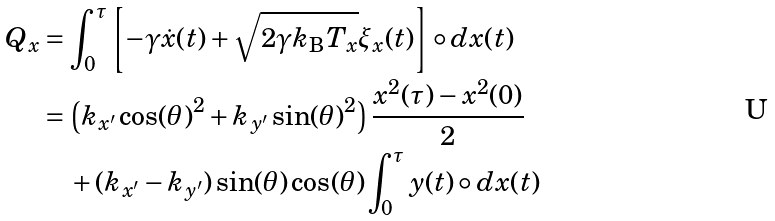<formula> <loc_0><loc_0><loc_500><loc_500>Q _ { x } & = \int _ { 0 } ^ { \tau } \left [ - \gamma \dot { x } ( t ) + \sqrt { 2 \gamma k _ { \mathrm B } T _ { x } } \xi _ { x } ( t ) \right ] \circ d x ( t ) \\ & = \left ( k _ { x ^ { \prime } } \cos ( \theta ) ^ { 2 } + k _ { y ^ { \prime } } \sin ( \theta ) ^ { 2 } \right ) \frac { x ^ { 2 } ( \tau ) - x ^ { 2 } ( 0 ) } { 2 } \\ & \quad + ( k _ { x ^ { \prime } } - k _ { y ^ { \prime } } ) \sin ( \theta ) \cos ( \theta ) \int _ { 0 } ^ { \tau } y ( t ) \circ d x ( t )</formula> 